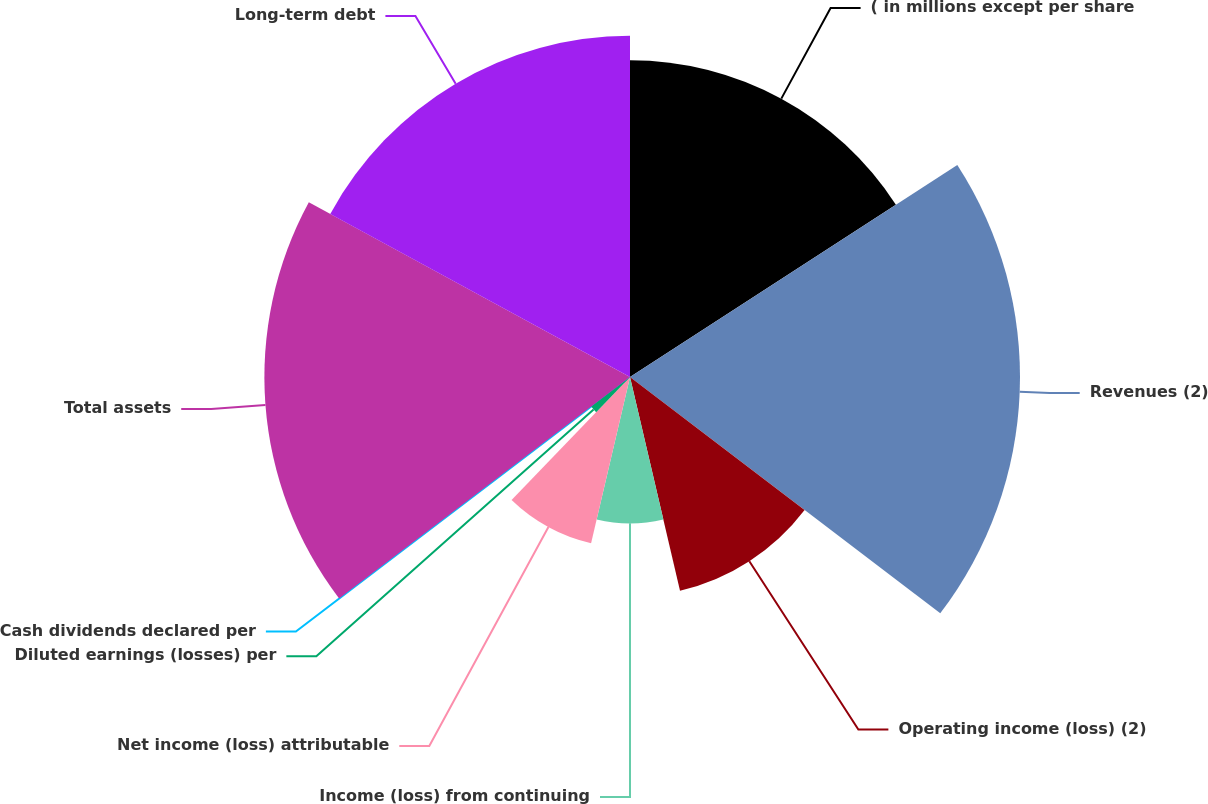Convert chart to OTSL. <chart><loc_0><loc_0><loc_500><loc_500><pie_chart><fcel>( in millions except per share<fcel>Revenues (2)<fcel>Operating income (loss) (2)<fcel>Income (loss) from continuing<fcel>Net income (loss) attributable<fcel>Diluted earnings (losses) per<fcel>Cash dividends declared per<fcel>Total assets<fcel>Long-term debt<nl><fcel>15.85%<fcel>19.51%<fcel>10.98%<fcel>7.32%<fcel>8.54%<fcel>2.44%<fcel>0.0%<fcel>18.29%<fcel>17.07%<nl></chart> 